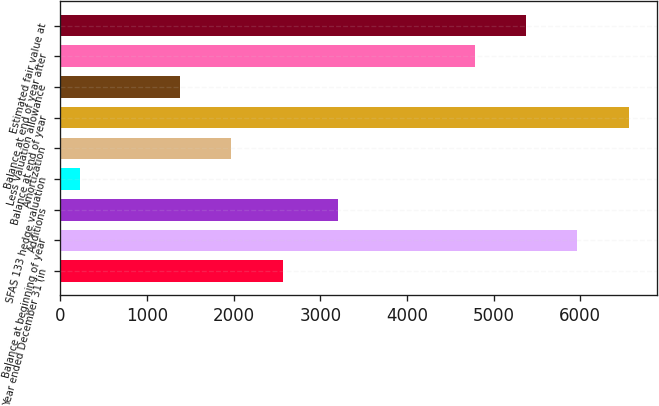<chart> <loc_0><loc_0><loc_500><loc_500><bar_chart><fcel>Year ended December 31 (in<fcel>Balance at beginning of year<fcel>Additions<fcel>SFAS 133 hedge valuation<fcel>Amortization<fcel>Balance at end of year<fcel>Less Valuation allowance<fcel>Balance at end of year after<fcel>Estimated fair value at<nl><fcel>2564.6<fcel>5967.6<fcel>3201<fcel>226<fcel>1971.3<fcel>6560.9<fcel>1378<fcel>4781<fcel>5374.3<nl></chart> 